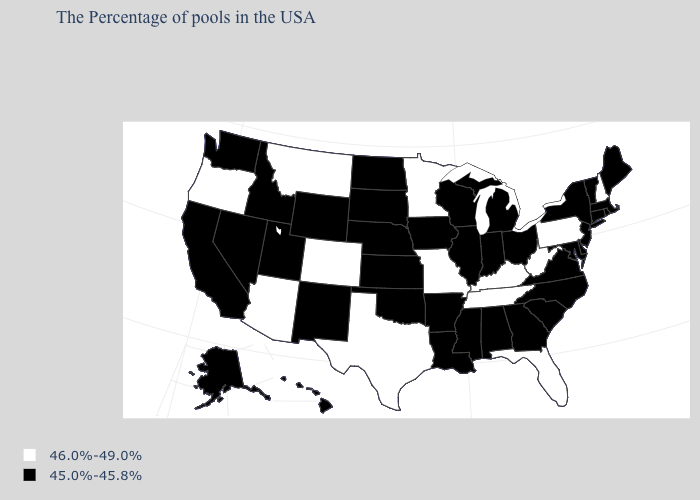What is the value of New Jersey?
Be succinct. 45.0%-45.8%. Name the states that have a value in the range 45.0%-45.8%?
Concise answer only. Maine, Massachusetts, Rhode Island, Vermont, Connecticut, New York, New Jersey, Delaware, Maryland, Virginia, North Carolina, South Carolina, Ohio, Georgia, Michigan, Indiana, Alabama, Wisconsin, Illinois, Mississippi, Louisiana, Arkansas, Iowa, Kansas, Nebraska, Oklahoma, South Dakota, North Dakota, Wyoming, New Mexico, Utah, Idaho, Nevada, California, Washington, Alaska, Hawaii. What is the lowest value in the USA?
Keep it brief. 45.0%-45.8%. Which states have the highest value in the USA?
Give a very brief answer. New Hampshire, Pennsylvania, West Virginia, Florida, Kentucky, Tennessee, Missouri, Minnesota, Texas, Colorado, Montana, Arizona, Oregon. What is the value of Arizona?
Answer briefly. 46.0%-49.0%. Among the states that border Indiana , which have the highest value?
Give a very brief answer. Kentucky. How many symbols are there in the legend?
Short answer required. 2. What is the value of Ohio?
Short answer required. 45.0%-45.8%. What is the highest value in states that border Arizona?
Short answer required. 46.0%-49.0%. What is the value of South Carolina?
Short answer required. 45.0%-45.8%. Does Arizona have the lowest value in the West?
Keep it brief. No. What is the value of Missouri?
Write a very short answer. 46.0%-49.0%. Name the states that have a value in the range 46.0%-49.0%?
Give a very brief answer. New Hampshire, Pennsylvania, West Virginia, Florida, Kentucky, Tennessee, Missouri, Minnesota, Texas, Colorado, Montana, Arizona, Oregon. Is the legend a continuous bar?
Answer briefly. No. Name the states that have a value in the range 45.0%-45.8%?
Give a very brief answer. Maine, Massachusetts, Rhode Island, Vermont, Connecticut, New York, New Jersey, Delaware, Maryland, Virginia, North Carolina, South Carolina, Ohio, Georgia, Michigan, Indiana, Alabama, Wisconsin, Illinois, Mississippi, Louisiana, Arkansas, Iowa, Kansas, Nebraska, Oklahoma, South Dakota, North Dakota, Wyoming, New Mexico, Utah, Idaho, Nevada, California, Washington, Alaska, Hawaii. 